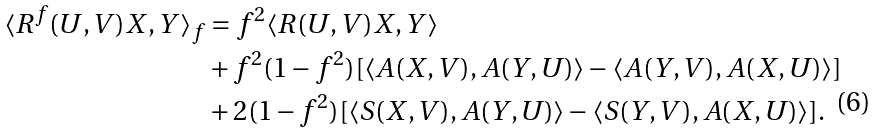Convert formula to latex. <formula><loc_0><loc_0><loc_500><loc_500>\langle R ^ { f } ( U , V ) X , Y \rangle _ { f } & = f ^ { 2 } \langle R ( U , V ) X , Y \rangle \\ & + f ^ { 2 } ( 1 - f ^ { 2 } ) [ \langle A ( X , V ) , A ( Y , U ) \rangle - \langle A ( Y , V ) , A ( X , U ) \rangle ] \\ & + 2 ( 1 - f ^ { 2 } ) [ \langle S ( X , V ) , A ( Y , U ) \rangle - \langle S ( Y , V ) , A ( X , U ) \rangle ] .</formula> 